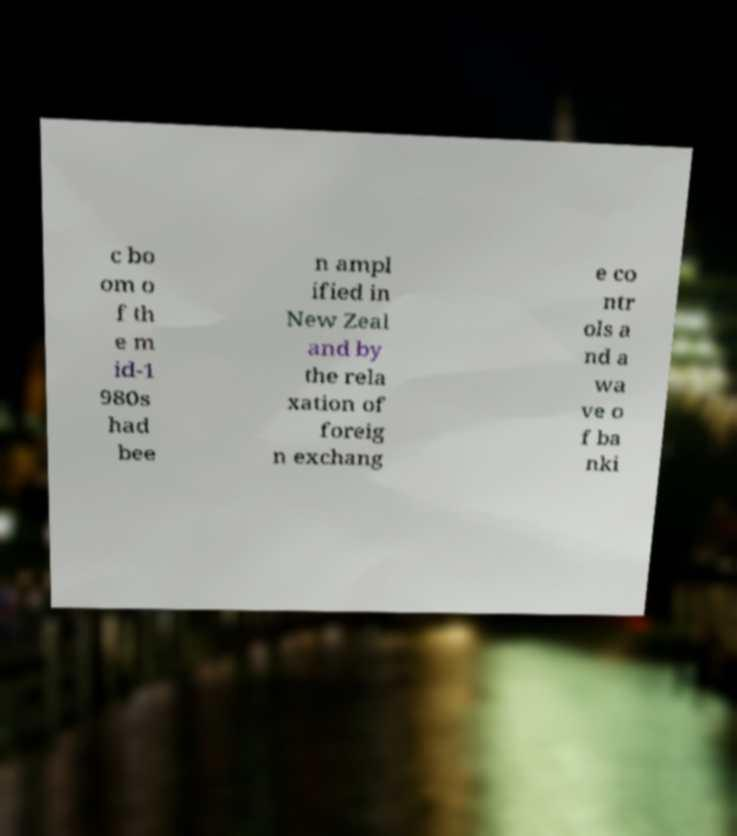Could you extract and type out the text from this image? c bo om o f th e m id-1 980s had bee n ampl ified in New Zeal and by the rela xation of foreig n exchang e co ntr ols a nd a wa ve o f ba nki 